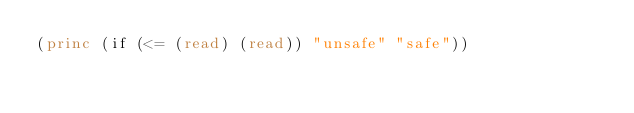<code> <loc_0><loc_0><loc_500><loc_500><_Lisp_>(princ (if (<= (read) (read)) "unsafe" "safe"))</code> 